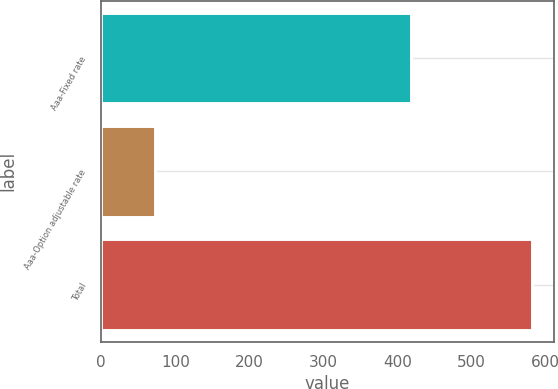Convert chart to OTSL. <chart><loc_0><loc_0><loc_500><loc_500><bar_chart><fcel>Aaa-Fixed rate<fcel>Aaa-Option adjustable rate<fcel>Total<nl><fcel>419<fcel>73<fcel>582<nl></chart> 